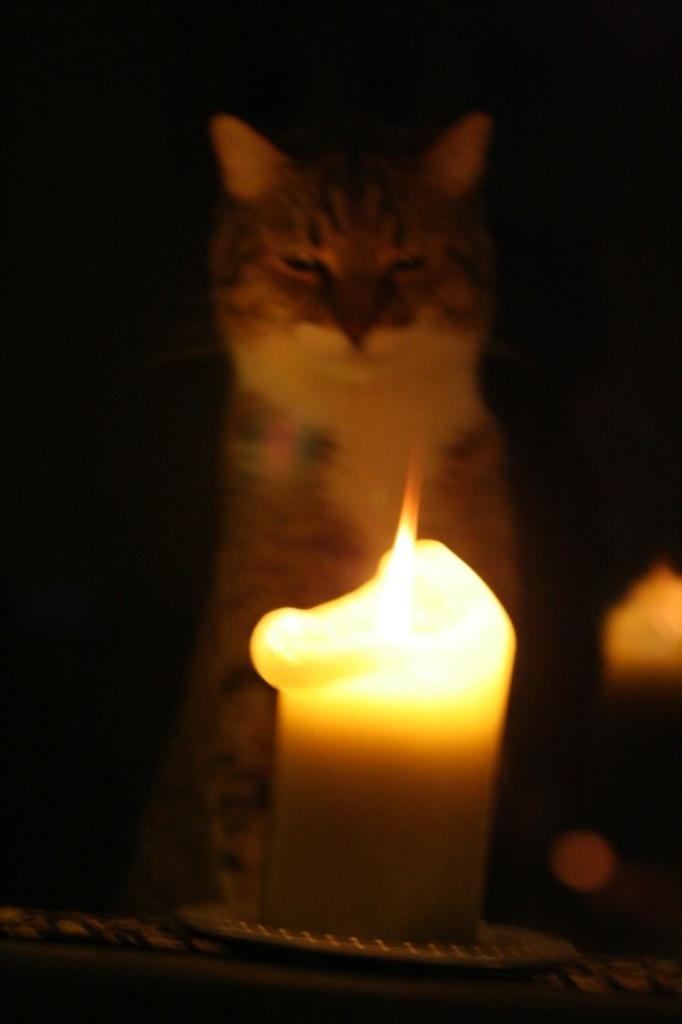What object is present on the plate in the image? There is a candle on the plate in the image. What is the cat's position in relation to the candle? The cat is visible behind the candle in the image. How would you describe the lighting in the image? The image appears to be slightly dark. What type of authority does the cat have over the candle in the image? There is no indication of authority in the image; the cat is simply visible behind the candle. Can you describe the taste of the candle in the image? Candles are not meant to be tasted, so it is not possible to describe their taste. 